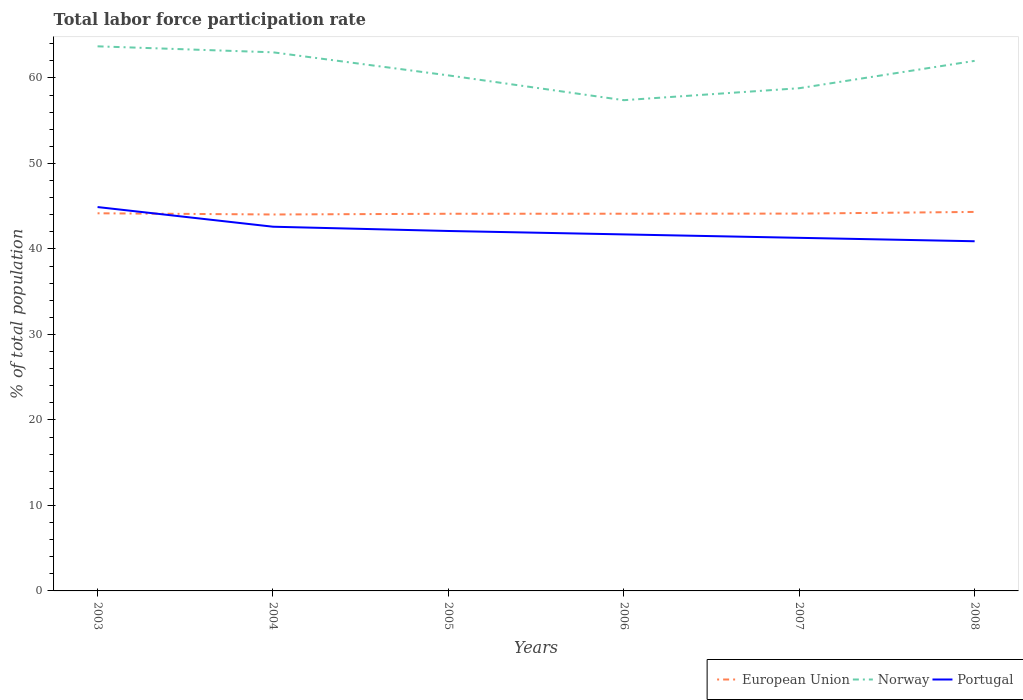How many different coloured lines are there?
Provide a succinct answer. 3. Across all years, what is the maximum total labor force participation rate in Portugal?
Make the answer very short. 40.9. In which year was the total labor force participation rate in Norway maximum?
Provide a succinct answer. 2006. What is the total total labor force participation rate in Portugal in the graph?
Your answer should be compact. 1.2. Is the total labor force participation rate in European Union strictly greater than the total labor force participation rate in Norway over the years?
Offer a very short reply. Yes. How many lines are there?
Your response must be concise. 3. Are the values on the major ticks of Y-axis written in scientific E-notation?
Provide a short and direct response. No. Does the graph contain grids?
Offer a very short reply. No. How many legend labels are there?
Make the answer very short. 3. What is the title of the graph?
Ensure brevity in your answer.  Total labor force participation rate. What is the label or title of the Y-axis?
Provide a short and direct response. % of total population. What is the % of total population in European Union in 2003?
Ensure brevity in your answer.  44.17. What is the % of total population of Norway in 2003?
Your response must be concise. 63.7. What is the % of total population of Portugal in 2003?
Your answer should be compact. 44.9. What is the % of total population in European Union in 2004?
Your answer should be very brief. 44.03. What is the % of total population in Norway in 2004?
Ensure brevity in your answer.  63. What is the % of total population in Portugal in 2004?
Keep it short and to the point. 42.6. What is the % of total population in European Union in 2005?
Your answer should be compact. 44.12. What is the % of total population of Norway in 2005?
Your response must be concise. 60.3. What is the % of total population of Portugal in 2005?
Your answer should be very brief. 42.1. What is the % of total population in European Union in 2006?
Give a very brief answer. 44.12. What is the % of total population of Norway in 2006?
Provide a succinct answer. 57.4. What is the % of total population of Portugal in 2006?
Your response must be concise. 41.7. What is the % of total population in European Union in 2007?
Offer a very short reply. 44.14. What is the % of total population in Norway in 2007?
Your answer should be compact. 58.8. What is the % of total population in Portugal in 2007?
Keep it short and to the point. 41.3. What is the % of total population in European Union in 2008?
Your answer should be very brief. 44.33. What is the % of total population in Norway in 2008?
Your response must be concise. 62. What is the % of total population in Portugal in 2008?
Make the answer very short. 40.9. Across all years, what is the maximum % of total population of European Union?
Keep it short and to the point. 44.33. Across all years, what is the maximum % of total population of Norway?
Your answer should be very brief. 63.7. Across all years, what is the maximum % of total population of Portugal?
Make the answer very short. 44.9. Across all years, what is the minimum % of total population in European Union?
Your answer should be very brief. 44.03. Across all years, what is the minimum % of total population of Norway?
Make the answer very short. 57.4. Across all years, what is the minimum % of total population in Portugal?
Your answer should be very brief. 40.9. What is the total % of total population in European Union in the graph?
Make the answer very short. 264.9. What is the total % of total population of Norway in the graph?
Make the answer very short. 365.2. What is the total % of total population of Portugal in the graph?
Keep it short and to the point. 253.5. What is the difference between the % of total population of European Union in 2003 and that in 2004?
Your answer should be compact. 0.14. What is the difference between the % of total population of Portugal in 2003 and that in 2004?
Your answer should be compact. 2.3. What is the difference between the % of total population in European Union in 2003 and that in 2005?
Ensure brevity in your answer.  0.06. What is the difference between the % of total population in Norway in 2003 and that in 2005?
Make the answer very short. 3.4. What is the difference between the % of total population in European Union in 2003 and that in 2006?
Make the answer very short. 0.05. What is the difference between the % of total population of Norway in 2003 and that in 2006?
Offer a terse response. 6.3. What is the difference between the % of total population of Portugal in 2003 and that in 2006?
Keep it short and to the point. 3.2. What is the difference between the % of total population of European Union in 2003 and that in 2007?
Your answer should be compact. 0.04. What is the difference between the % of total population in Portugal in 2003 and that in 2007?
Your response must be concise. 3.6. What is the difference between the % of total population of European Union in 2003 and that in 2008?
Make the answer very short. -0.16. What is the difference between the % of total population of Norway in 2003 and that in 2008?
Your response must be concise. 1.7. What is the difference between the % of total population in Portugal in 2003 and that in 2008?
Make the answer very short. 4. What is the difference between the % of total population in European Union in 2004 and that in 2005?
Provide a succinct answer. -0.09. What is the difference between the % of total population in Portugal in 2004 and that in 2005?
Offer a terse response. 0.5. What is the difference between the % of total population of European Union in 2004 and that in 2006?
Your answer should be very brief. -0.09. What is the difference between the % of total population in Portugal in 2004 and that in 2006?
Give a very brief answer. 0.9. What is the difference between the % of total population of European Union in 2004 and that in 2007?
Ensure brevity in your answer.  -0.1. What is the difference between the % of total population in Portugal in 2004 and that in 2007?
Your response must be concise. 1.3. What is the difference between the % of total population in European Union in 2004 and that in 2008?
Offer a very short reply. -0.3. What is the difference between the % of total population of Portugal in 2004 and that in 2008?
Make the answer very short. 1.7. What is the difference between the % of total population of European Union in 2005 and that in 2006?
Ensure brevity in your answer.  -0. What is the difference between the % of total population in Portugal in 2005 and that in 2006?
Provide a short and direct response. 0.4. What is the difference between the % of total population in European Union in 2005 and that in 2007?
Provide a succinct answer. -0.02. What is the difference between the % of total population of Norway in 2005 and that in 2007?
Provide a short and direct response. 1.5. What is the difference between the % of total population of European Union in 2005 and that in 2008?
Provide a succinct answer. -0.21. What is the difference between the % of total population in European Union in 2006 and that in 2007?
Provide a succinct answer. -0.01. What is the difference between the % of total population of Norway in 2006 and that in 2007?
Give a very brief answer. -1.4. What is the difference between the % of total population in European Union in 2006 and that in 2008?
Offer a very short reply. -0.21. What is the difference between the % of total population in Norway in 2006 and that in 2008?
Provide a short and direct response. -4.6. What is the difference between the % of total population in Portugal in 2006 and that in 2008?
Ensure brevity in your answer.  0.8. What is the difference between the % of total population of European Union in 2007 and that in 2008?
Provide a short and direct response. -0.2. What is the difference between the % of total population of European Union in 2003 and the % of total population of Norway in 2004?
Offer a very short reply. -18.83. What is the difference between the % of total population in European Union in 2003 and the % of total population in Portugal in 2004?
Provide a short and direct response. 1.57. What is the difference between the % of total population of Norway in 2003 and the % of total population of Portugal in 2004?
Give a very brief answer. 21.1. What is the difference between the % of total population in European Union in 2003 and the % of total population in Norway in 2005?
Your response must be concise. -16.13. What is the difference between the % of total population in European Union in 2003 and the % of total population in Portugal in 2005?
Give a very brief answer. 2.07. What is the difference between the % of total population of Norway in 2003 and the % of total population of Portugal in 2005?
Offer a terse response. 21.6. What is the difference between the % of total population in European Union in 2003 and the % of total population in Norway in 2006?
Keep it short and to the point. -13.23. What is the difference between the % of total population of European Union in 2003 and the % of total population of Portugal in 2006?
Keep it short and to the point. 2.47. What is the difference between the % of total population of European Union in 2003 and the % of total population of Norway in 2007?
Your answer should be compact. -14.63. What is the difference between the % of total population of European Union in 2003 and the % of total population of Portugal in 2007?
Provide a succinct answer. 2.87. What is the difference between the % of total population in Norway in 2003 and the % of total population in Portugal in 2007?
Provide a succinct answer. 22.4. What is the difference between the % of total population of European Union in 2003 and the % of total population of Norway in 2008?
Your answer should be very brief. -17.83. What is the difference between the % of total population of European Union in 2003 and the % of total population of Portugal in 2008?
Keep it short and to the point. 3.27. What is the difference between the % of total population in Norway in 2003 and the % of total population in Portugal in 2008?
Your answer should be very brief. 22.8. What is the difference between the % of total population of European Union in 2004 and the % of total population of Norway in 2005?
Ensure brevity in your answer.  -16.27. What is the difference between the % of total population in European Union in 2004 and the % of total population in Portugal in 2005?
Provide a succinct answer. 1.93. What is the difference between the % of total population in Norway in 2004 and the % of total population in Portugal in 2005?
Your answer should be compact. 20.9. What is the difference between the % of total population in European Union in 2004 and the % of total population in Norway in 2006?
Offer a terse response. -13.37. What is the difference between the % of total population in European Union in 2004 and the % of total population in Portugal in 2006?
Keep it short and to the point. 2.33. What is the difference between the % of total population of Norway in 2004 and the % of total population of Portugal in 2006?
Ensure brevity in your answer.  21.3. What is the difference between the % of total population of European Union in 2004 and the % of total population of Norway in 2007?
Give a very brief answer. -14.77. What is the difference between the % of total population in European Union in 2004 and the % of total population in Portugal in 2007?
Give a very brief answer. 2.73. What is the difference between the % of total population of Norway in 2004 and the % of total population of Portugal in 2007?
Your answer should be compact. 21.7. What is the difference between the % of total population of European Union in 2004 and the % of total population of Norway in 2008?
Provide a short and direct response. -17.97. What is the difference between the % of total population in European Union in 2004 and the % of total population in Portugal in 2008?
Your response must be concise. 3.13. What is the difference between the % of total population of Norway in 2004 and the % of total population of Portugal in 2008?
Ensure brevity in your answer.  22.1. What is the difference between the % of total population in European Union in 2005 and the % of total population in Norway in 2006?
Your response must be concise. -13.28. What is the difference between the % of total population in European Union in 2005 and the % of total population in Portugal in 2006?
Your answer should be very brief. 2.42. What is the difference between the % of total population of Norway in 2005 and the % of total population of Portugal in 2006?
Keep it short and to the point. 18.6. What is the difference between the % of total population in European Union in 2005 and the % of total population in Norway in 2007?
Give a very brief answer. -14.68. What is the difference between the % of total population in European Union in 2005 and the % of total population in Portugal in 2007?
Give a very brief answer. 2.82. What is the difference between the % of total population in Norway in 2005 and the % of total population in Portugal in 2007?
Your answer should be compact. 19. What is the difference between the % of total population of European Union in 2005 and the % of total population of Norway in 2008?
Offer a terse response. -17.88. What is the difference between the % of total population in European Union in 2005 and the % of total population in Portugal in 2008?
Provide a succinct answer. 3.22. What is the difference between the % of total population of European Union in 2006 and the % of total population of Norway in 2007?
Provide a succinct answer. -14.68. What is the difference between the % of total population in European Union in 2006 and the % of total population in Portugal in 2007?
Your answer should be compact. 2.82. What is the difference between the % of total population in European Union in 2006 and the % of total population in Norway in 2008?
Your answer should be compact. -17.88. What is the difference between the % of total population in European Union in 2006 and the % of total population in Portugal in 2008?
Your answer should be very brief. 3.22. What is the difference between the % of total population of European Union in 2007 and the % of total population of Norway in 2008?
Offer a terse response. -17.86. What is the difference between the % of total population of European Union in 2007 and the % of total population of Portugal in 2008?
Provide a succinct answer. 3.24. What is the difference between the % of total population of Norway in 2007 and the % of total population of Portugal in 2008?
Your answer should be very brief. 17.9. What is the average % of total population of European Union per year?
Keep it short and to the point. 44.15. What is the average % of total population in Norway per year?
Offer a terse response. 60.87. What is the average % of total population in Portugal per year?
Provide a succinct answer. 42.25. In the year 2003, what is the difference between the % of total population in European Union and % of total population in Norway?
Your answer should be very brief. -19.53. In the year 2003, what is the difference between the % of total population of European Union and % of total population of Portugal?
Offer a terse response. -0.73. In the year 2003, what is the difference between the % of total population in Norway and % of total population in Portugal?
Offer a very short reply. 18.8. In the year 2004, what is the difference between the % of total population of European Union and % of total population of Norway?
Ensure brevity in your answer.  -18.97. In the year 2004, what is the difference between the % of total population of European Union and % of total population of Portugal?
Give a very brief answer. 1.43. In the year 2004, what is the difference between the % of total population in Norway and % of total population in Portugal?
Offer a terse response. 20.4. In the year 2005, what is the difference between the % of total population in European Union and % of total population in Norway?
Your answer should be compact. -16.18. In the year 2005, what is the difference between the % of total population in European Union and % of total population in Portugal?
Ensure brevity in your answer.  2.02. In the year 2005, what is the difference between the % of total population of Norway and % of total population of Portugal?
Your response must be concise. 18.2. In the year 2006, what is the difference between the % of total population of European Union and % of total population of Norway?
Offer a terse response. -13.28. In the year 2006, what is the difference between the % of total population in European Union and % of total population in Portugal?
Make the answer very short. 2.42. In the year 2006, what is the difference between the % of total population in Norway and % of total population in Portugal?
Provide a short and direct response. 15.7. In the year 2007, what is the difference between the % of total population of European Union and % of total population of Norway?
Offer a terse response. -14.66. In the year 2007, what is the difference between the % of total population of European Union and % of total population of Portugal?
Offer a very short reply. 2.84. In the year 2008, what is the difference between the % of total population in European Union and % of total population in Norway?
Ensure brevity in your answer.  -17.67. In the year 2008, what is the difference between the % of total population in European Union and % of total population in Portugal?
Offer a very short reply. 3.43. In the year 2008, what is the difference between the % of total population in Norway and % of total population in Portugal?
Your response must be concise. 21.1. What is the ratio of the % of total population in European Union in 2003 to that in 2004?
Offer a terse response. 1. What is the ratio of the % of total population of Norway in 2003 to that in 2004?
Provide a succinct answer. 1.01. What is the ratio of the % of total population of Portugal in 2003 to that in 2004?
Provide a succinct answer. 1.05. What is the ratio of the % of total population of Norway in 2003 to that in 2005?
Offer a terse response. 1.06. What is the ratio of the % of total population of Portugal in 2003 to that in 2005?
Provide a short and direct response. 1.07. What is the ratio of the % of total population of Norway in 2003 to that in 2006?
Ensure brevity in your answer.  1.11. What is the ratio of the % of total population in Portugal in 2003 to that in 2006?
Provide a short and direct response. 1.08. What is the ratio of the % of total population in European Union in 2003 to that in 2007?
Offer a terse response. 1. What is the ratio of the % of total population of Portugal in 2003 to that in 2007?
Offer a very short reply. 1.09. What is the ratio of the % of total population of European Union in 2003 to that in 2008?
Keep it short and to the point. 1. What is the ratio of the % of total population of Norway in 2003 to that in 2008?
Provide a succinct answer. 1.03. What is the ratio of the % of total population in Portugal in 2003 to that in 2008?
Offer a terse response. 1.1. What is the ratio of the % of total population in Norway in 2004 to that in 2005?
Your response must be concise. 1.04. What is the ratio of the % of total population in Portugal in 2004 to that in 2005?
Offer a very short reply. 1.01. What is the ratio of the % of total population of European Union in 2004 to that in 2006?
Give a very brief answer. 1. What is the ratio of the % of total population in Norway in 2004 to that in 2006?
Make the answer very short. 1.1. What is the ratio of the % of total population of Portugal in 2004 to that in 2006?
Provide a short and direct response. 1.02. What is the ratio of the % of total population of Norway in 2004 to that in 2007?
Offer a very short reply. 1.07. What is the ratio of the % of total population of Portugal in 2004 to that in 2007?
Offer a very short reply. 1.03. What is the ratio of the % of total population in European Union in 2004 to that in 2008?
Give a very brief answer. 0.99. What is the ratio of the % of total population of Norway in 2004 to that in 2008?
Your answer should be compact. 1.02. What is the ratio of the % of total population of Portugal in 2004 to that in 2008?
Keep it short and to the point. 1.04. What is the ratio of the % of total population of European Union in 2005 to that in 2006?
Provide a succinct answer. 1. What is the ratio of the % of total population of Norway in 2005 to that in 2006?
Offer a very short reply. 1.05. What is the ratio of the % of total population of Portugal in 2005 to that in 2006?
Offer a terse response. 1.01. What is the ratio of the % of total population of European Union in 2005 to that in 2007?
Keep it short and to the point. 1. What is the ratio of the % of total population of Norway in 2005 to that in 2007?
Make the answer very short. 1.03. What is the ratio of the % of total population in Portugal in 2005 to that in 2007?
Make the answer very short. 1.02. What is the ratio of the % of total population in Norway in 2005 to that in 2008?
Offer a terse response. 0.97. What is the ratio of the % of total population of Portugal in 2005 to that in 2008?
Your response must be concise. 1.03. What is the ratio of the % of total population of Norway in 2006 to that in 2007?
Your answer should be compact. 0.98. What is the ratio of the % of total population of Portugal in 2006 to that in 2007?
Provide a short and direct response. 1.01. What is the ratio of the % of total population in European Union in 2006 to that in 2008?
Your answer should be compact. 1. What is the ratio of the % of total population of Norway in 2006 to that in 2008?
Ensure brevity in your answer.  0.93. What is the ratio of the % of total population of Portugal in 2006 to that in 2008?
Your answer should be compact. 1.02. What is the ratio of the % of total population of European Union in 2007 to that in 2008?
Your response must be concise. 1. What is the ratio of the % of total population of Norway in 2007 to that in 2008?
Provide a short and direct response. 0.95. What is the ratio of the % of total population of Portugal in 2007 to that in 2008?
Make the answer very short. 1.01. What is the difference between the highest and the second highest % of total population in European Union?
Make the answer very short. 0.16. What is the difference between the highest and the second highest % of total population in Norway?
Offer a terse response. 0.7. What is the difference between the highest and the second highest % of total population of Portugal?
Keep it short and to the point. 2.3. What is the difference between the highest and the lowest % of total population in European Union?
Offer a terse response. 0.3. What is the difference between the highest and the lowest % of total population in Norway?
Offer a terse response. 6.3. What is the difference between the highest and the lowest % of total population of Portugal?
Ensure brevity in your answer.  4. 